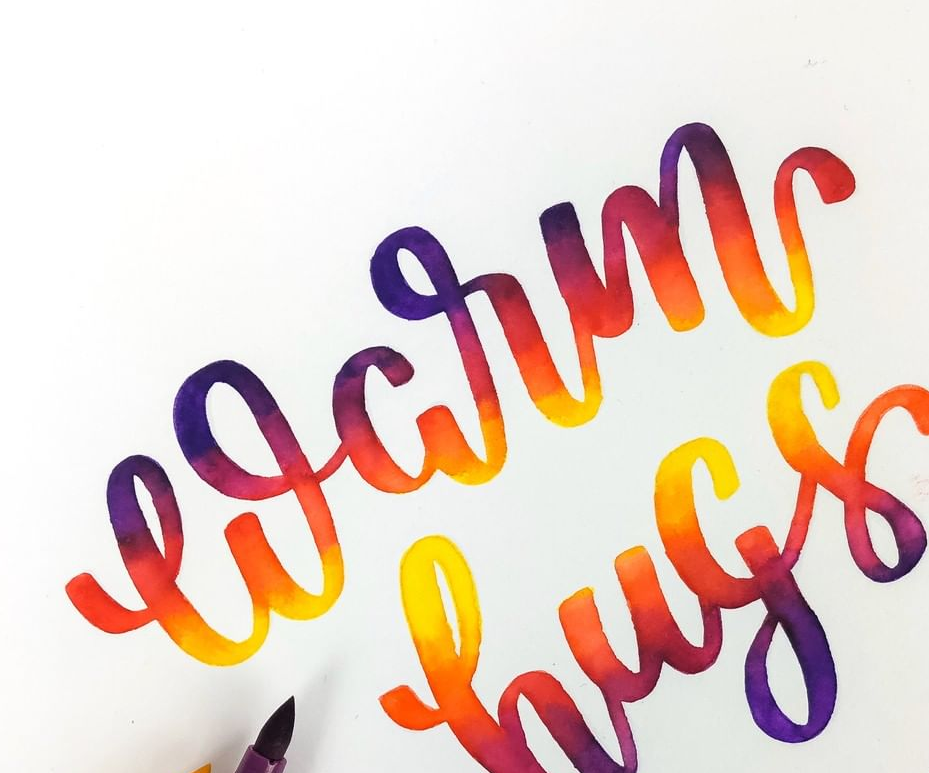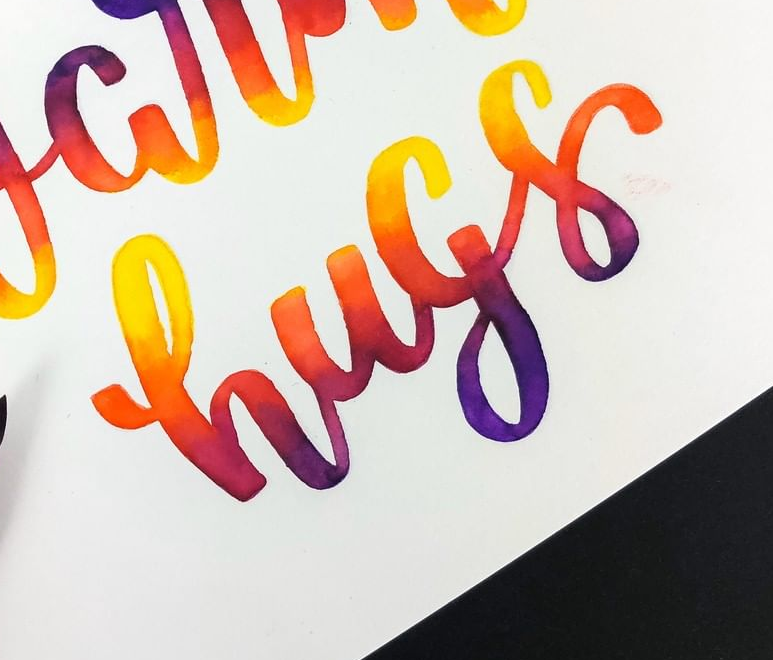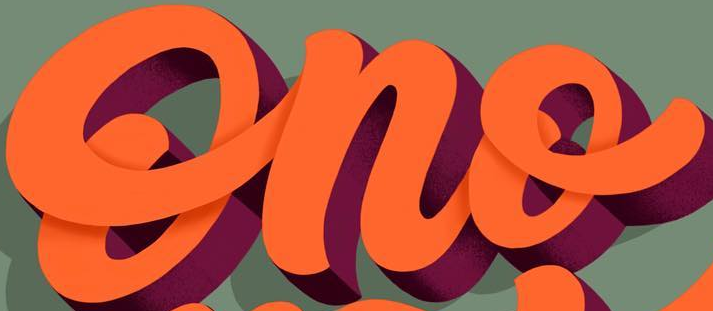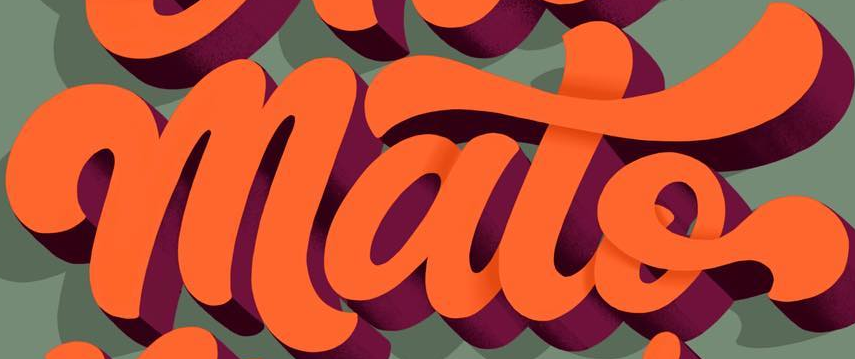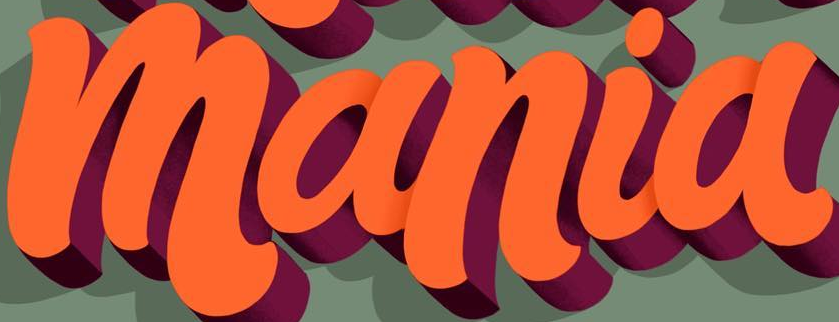Transcribe the words shown in these images in order, separated by a semicolon. warm; hugs; Ono; mato; mania 